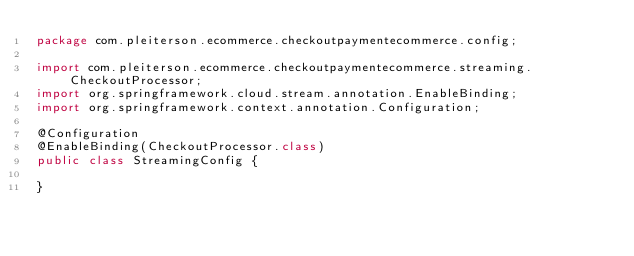<code> <loc_0><loc_0><loc_500><loc_500><_Java_>package com.pleiterson.ecommerce.checkoutpaymentecommerce.config;

import com.pleiterson.ecommerce.checkoutpaymentecommerce.streaming.CheckoutProcessor;
import org.springframework.cloud.stream.annotation.EnableBinding;
import org.springframework.context.annotation.Configuration;

@Configuration
@EnableBinding(CheckoutProcessor.class)
public class StreamingConfig {
    
}
</code> 